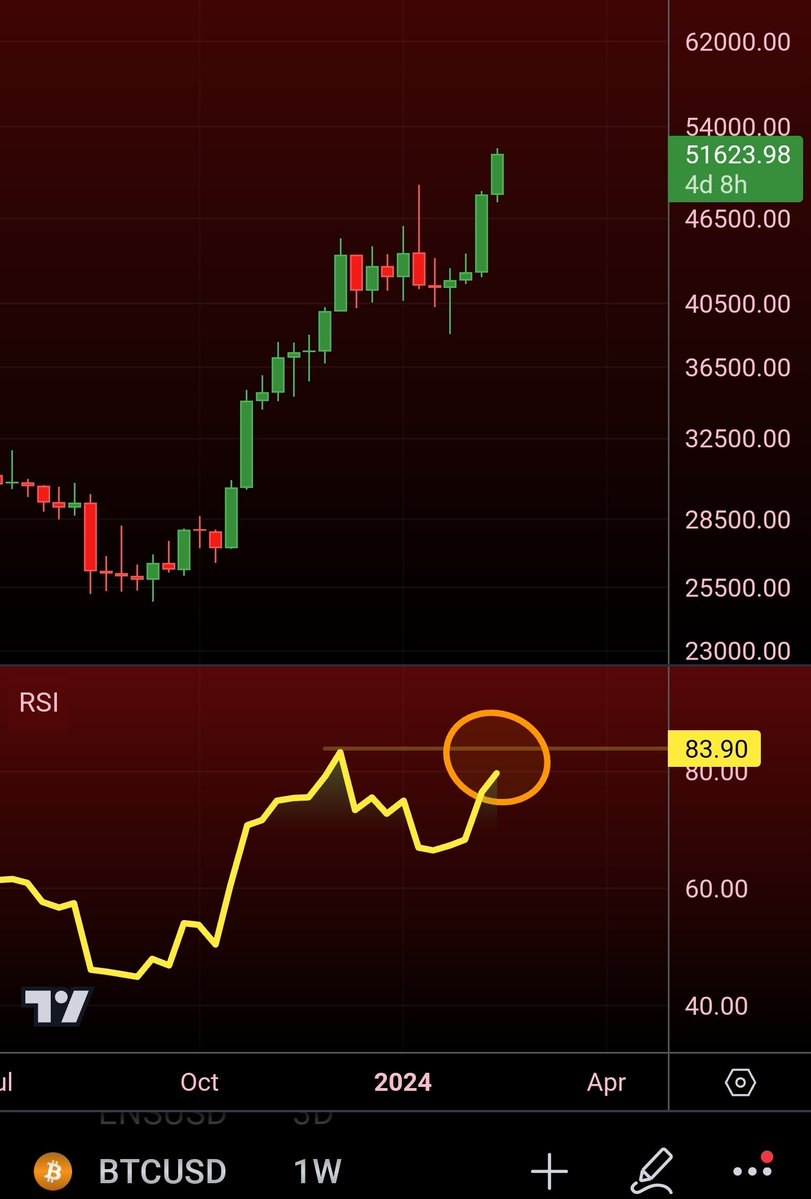should i buy or sell ? I'm sorry, but I cannot provide specific financial advice, including recommendations to buy or sell securities, cryptocurrencies, or any other assets. The image you've shown appears to be a candlestick chart for Bitcoin (BTCUSD) with a weekly timeframe, and it includes an indicator called the Relative Strength Index (RSI).

The RSI is a momentum indicator that measures the magnitude of recent price changes to evaluate overbought or oversold conditions in the price of a stock or other asset. An RSI reading above 70 is typically considered overbought, while an RSI below 30 is considered oversold. In the image, the RSI is marked at 83.90, which is in the overbought territory. However, RSI is just one of many indicators traders use to make decisions, and it should not be used in isolation.

When making investment decisions, it's essential to do your research, consider your investment strategy, risk tolerance, and financial goals, and consult with a financial advisor if needed. Markets can be unpredictable, and past performance is not indicative of future results. 